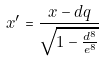Convert formula to latex. <formula><loc_0><loc_0><loc_500><loc_500>x ^ { \prime } = \frac { x - d q } { \sqrt { 1 - \frac { d ^ { 8 } } { e ^ { 8 } } } }</formula> 